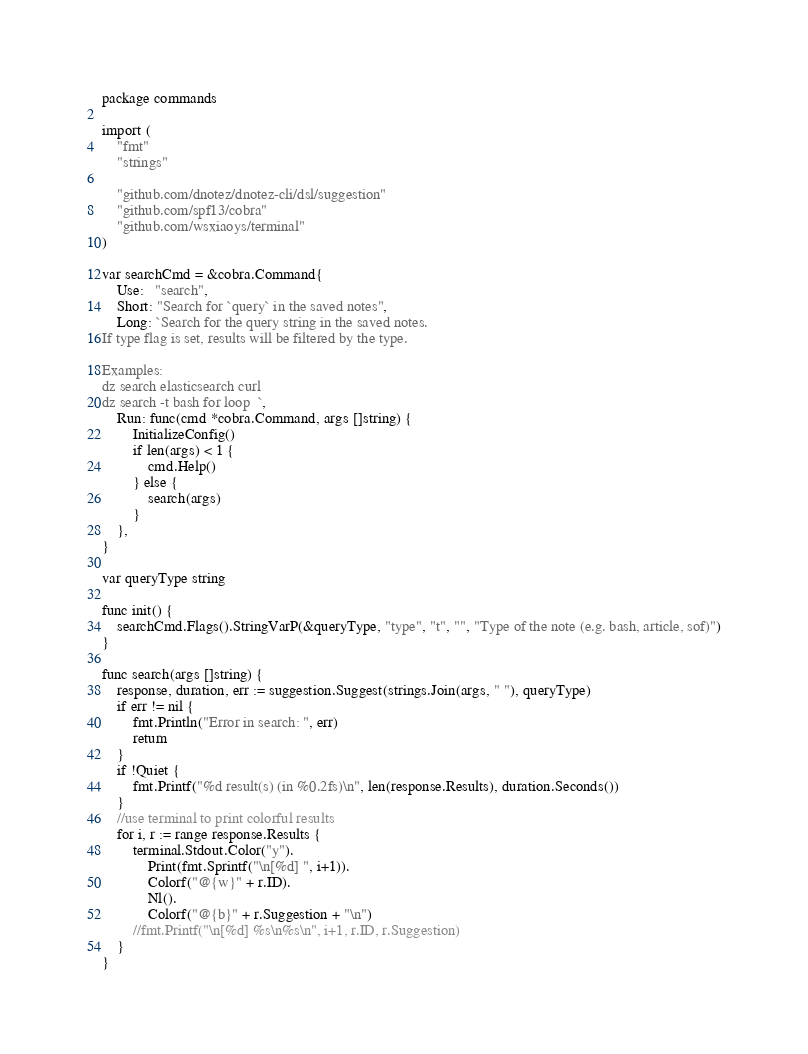<code> <loc_0><loc_0><loc_500><loc_500><_Go_>package commands

import (
	"fmt"
	"strings"

	"github.com/dnotez/dnotez-cli/dsl/suggestion"
	"github.com/spf13/cobra"
	"github.com/wsxiaoys/terminal"
)

var searchCmd = &cobra.Command{
	Use:   "search",
	Short: "Search for `query` in the saved notes",
	Long: `Search for the query string in the saved notes.
If type flag is set, results will be filtered by the type.

Examples:
dz search elasticsearch curl
dz search -t bash for loop	`,
	Run: func(cmd *cobra.Command, args []string) {
		InitializeConfig()
		if len(args) < 1 {
			cmd.Help()
		} else {
			search(args)
		}
	},
}

var queryType string

func init() {
	searchCmd.Flags().StringVarP(&queryType, "type", "t", "", "Type of the note (e.g. bash, article, sof)")
}

func search(args []string) {
	response, duration, err := suggestion.Suggest(strings.Join(args, " "), queryType)
	if err != nil {
		fmt.Println("Error in search: ", err)
		return
	}
	if !Quiet {
		fmt.Printf("%d result(s) (in %0.2fs)\n", len(response.Results), duration.Seconds())
	}
	//use terminal to print colorful results
	for i, r := range response.Results {
		terminal.Stdout.Color("y").
			Print(fmt.Sprintf("\n[%d] ", i+1)).
			Colorf("@{w}" + r.ID).
			Nl().
			Colorf("@{b}" + r.Suggestion + "\n")
		//fmt.Printf("\n[%d] %s\n%s\n", i+1, r.ID, r.Suggestion)
	}
}
</code> 